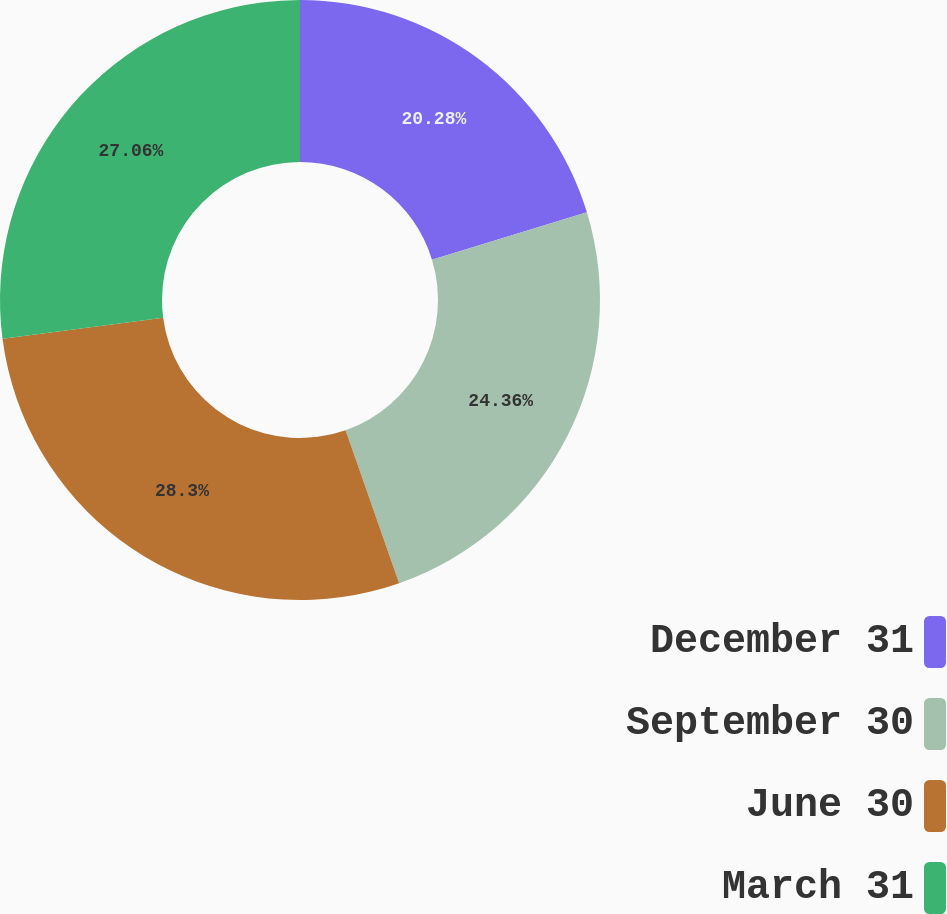<chart> <loc_0><loc_0><loc_500><loc_500><pie_chart><fcel>December 31<fcel>September 30<fcel>June 30<fcel>March 31<nl><fcel>20.28%<fcel>24.36%<fcel>28.3%<fcel>27.06%<nl></chart> 